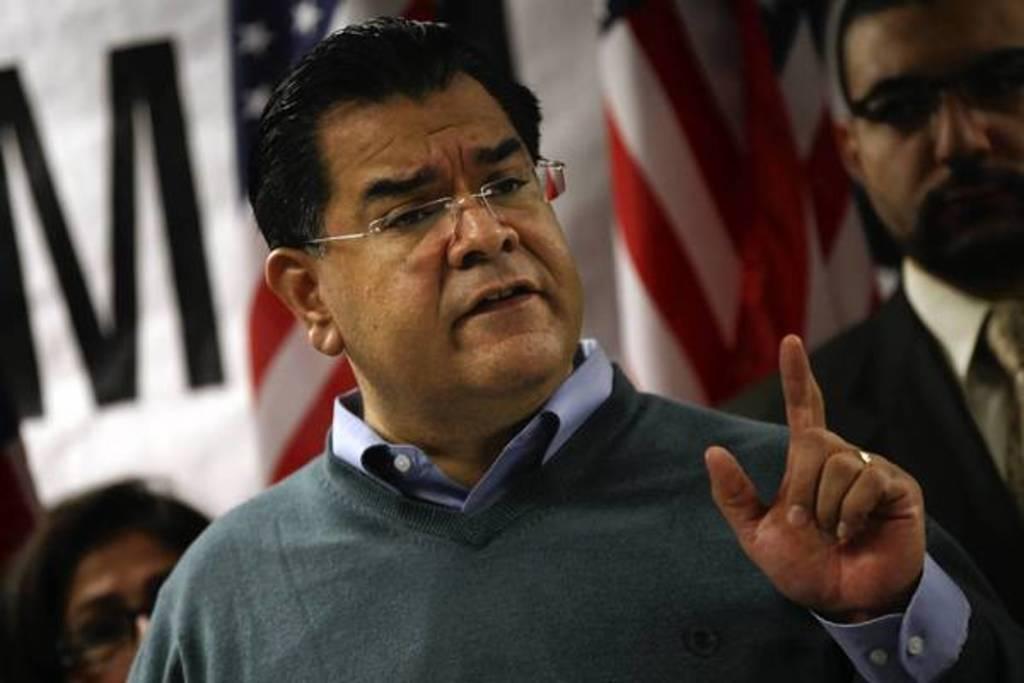Describe this image in one or two sentences. This picture describes about few people, in the middle of the image we can see a man, he wore spectacles, in the background we can see flags. 